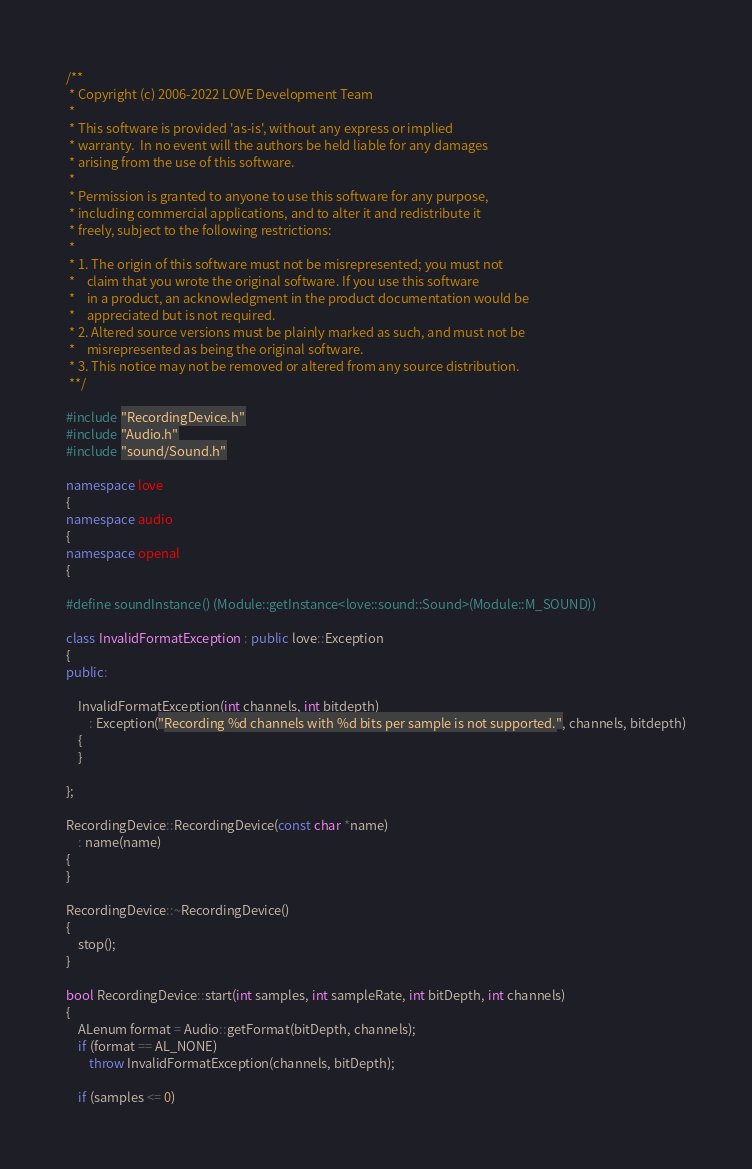<code> <loc_0><loc_0><loc_500><loc_500><_C++_>/**
 * Copyright (c) 2006-2022 LOVE Development Team
 *
 * This software is provided 'as-is', without any express or implied
 * warranty.  In no event will the authors be held liable for any damages
 * arising from the use of this software.
 *
 * Permission is granted to anyone to use this software for any purpose,
 * including commercial applications, and to alter it and redistribute it
 * freely, subject to the following restrictions:
 *
 * 1. The origin of this software must not be misrepresented; you must not
 *    claim that you wrote the original software. If you use this software
 *    in a product, an acknowledgment in the product documentation would be
 *    appreciated but is not required.
 * 2. Altered source versions must be plainly marked as such, and must not be
 *    misrepresented as being the original software.
 * 3. This notice may not be removed or altered from any source distribution.
 **/

#include "RecordingDevice.h"
#include "Audio.h"
#include "sound/Sound.h"

namespace love
{
namespace audio
{
namespace openal
{

#define soundInstance() (Module::getInstance<love::sound::Sound>(Module::M_SOUND))

class InvalidFormatException : public love::Exception
{
public:

	InvalidFormatException(int channels, int bitdepth)
		: Exception("Recording %d channels with %d bits per sample is not supported.", channels, bitdepth)
	{
	}

};

RecordingDevice::RecordingDevice(const char *name) 
	: name(name)
{
}

RecordingDevice::~RecordingDevice()
{
	stop();
}

bool RecordingDevice::start(int samples, int sampleRate, int bitDepth, int channels)
{
	ALenum format = Audio::getFormat(bitDepth, channels);
	if (format == AL_NONE)
		throw InvalidFormatException(channels, bitDepth);

	if (samples <= 0)</code> 